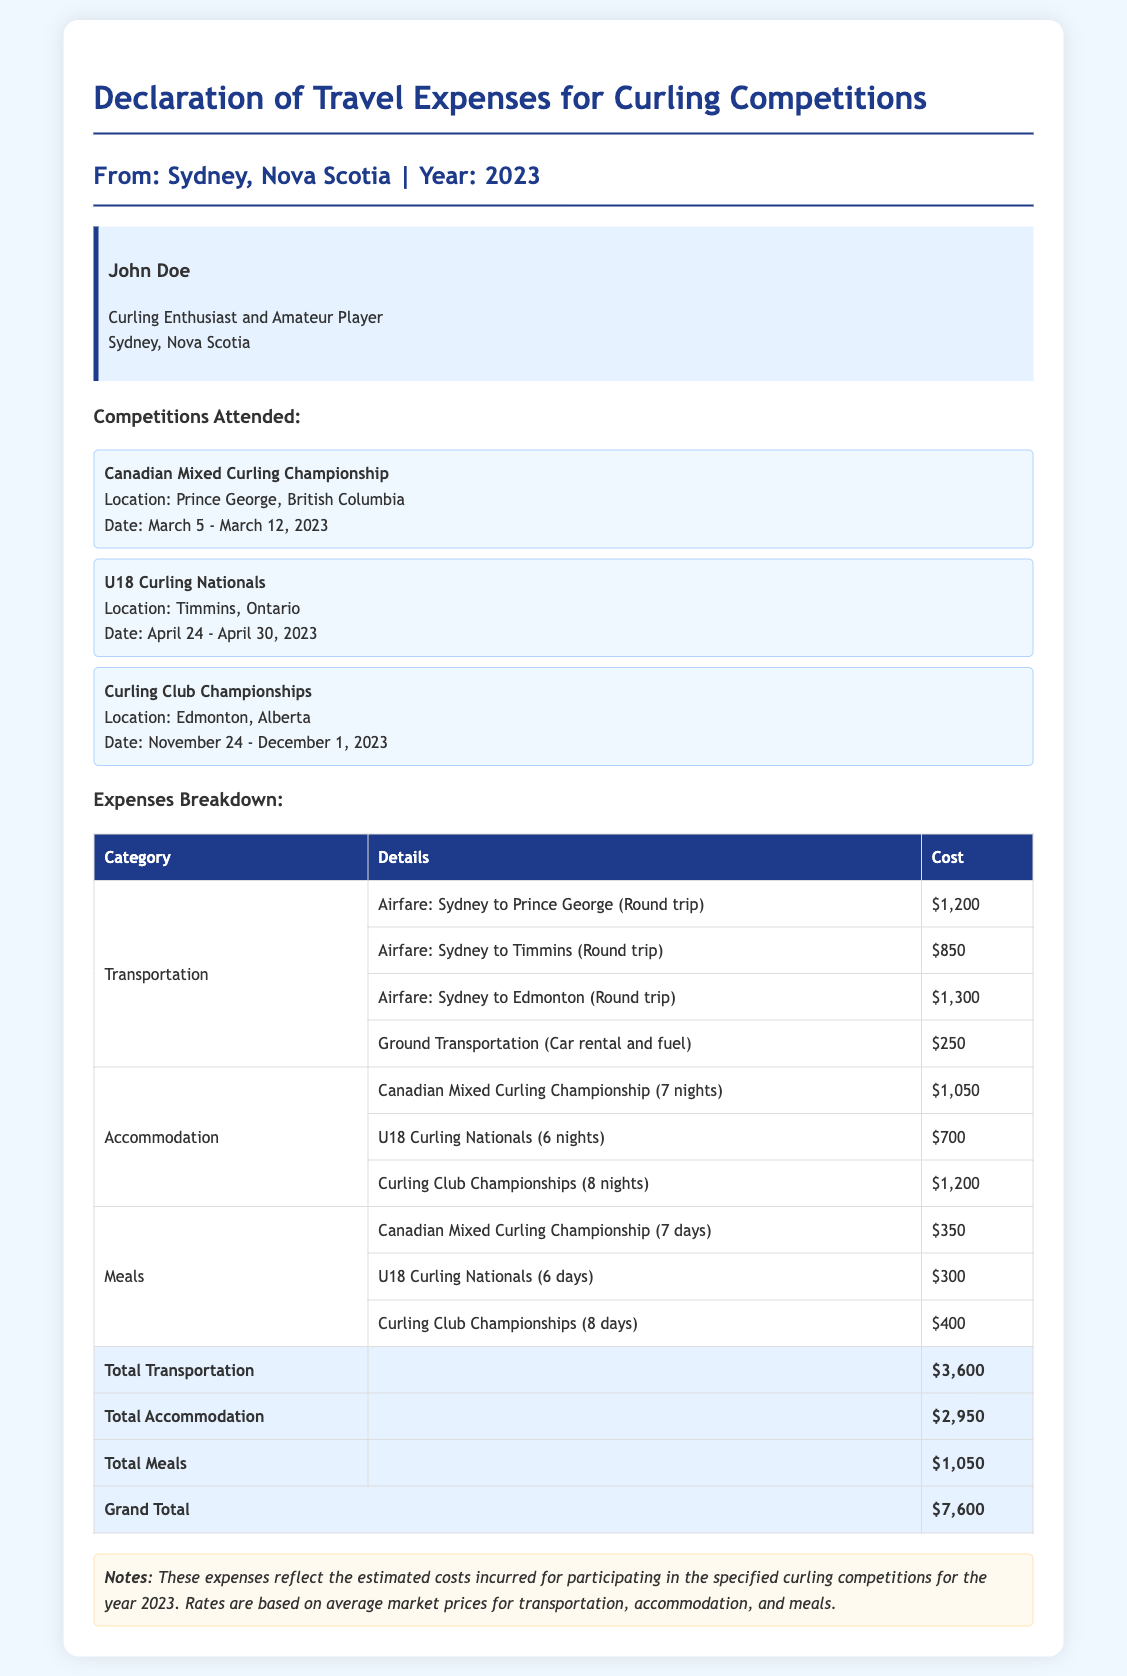What is the total transportation cost? The total transportation cost is provided in the expenses breakdown section, which is $3,600.
Answer: $3,600 Where was the Canadian Mixed Curling Championship held? The location of the Canadian Mixed Curling Championship is noted in the document as Prince George, British Columbia.
Answer: Prince George, British Columbia How many nights did John Doe stay for the U18 Curling Nationals? The number of nights stayed for the U18 Curling Nationals is listed as 6 nights in the accommodation section.
Answer: 6 nights What is the grand total of all expenses? The grand total is calculated as the sum of transportation, accommodation, and meal costs, given as $7,600.
Answer: $7,600 How many days of meals are accounted for during the Curling Club Championships? The number of days of meals for the Curling Club Championships is specified as 8 days in the meals section.
Answer: 8 days What type of document is this? The document is categorized as a Declaration of Travel Expenses for Curling Competitions.
Answer: Declaration of Travel Expenses Who is the declarant of the travel expenses? The identity section provides the name of the declarant, which is John Doe.
Answer: John Doe What is the cost of accommodation for the Canadian Mixed Curling Championship? The cost of accommodation for the Canadian Mixed Curling Championship is detailed as $1,050.
Answer: $1,050 Which competition had the highest airfare cost? The airfare costs for the competitions are listed, with the highest cost being for the Curling Club Championships at $1,300.
Answer: $1,300 